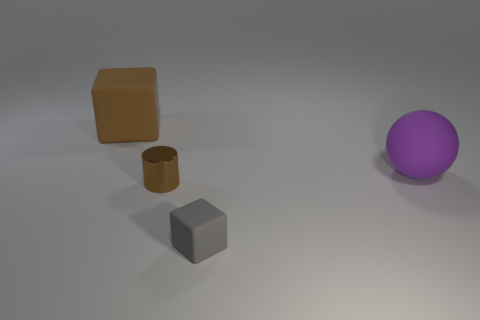Is there any other thing that has the same material as the small brown object?
Offer a very short reply. No. Is the shape of the matte object that is in front of the tiny cylinder the same as  the tiny brown metallic thing?
Keep it short and to the point. No. Are there fewer big purple cubes than purple things?
Provide a short and direct response. Yes. Are there any other things that have the same color as the large matte sphere?
Your response must be concise. No. What shape is the brown thing that is in front of the big cube?
Keep it short and to the point. Cylinder. Do the tiny cylinder and the block that is behind the gray cube have the same color?
Your answer should be compact. Yes. Are there an equal number of gray rubber objects that are to the left of the small gray thing and brown metal cylinders that are right of the brown cylinder?
Offer a very short reply. Yes. How many other objects are the same size as the brown metal object?
Your response must be concise. 1. What is the size of the brown cylinder?
Give a very brief answer. Small. Are the brown cylinder and the big object behind the large ball made of the same material?
Offer a very short reply. No. 